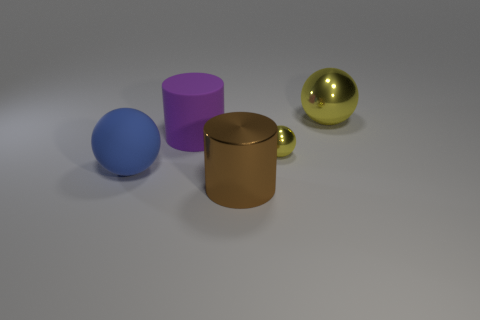Subtract all metal balls. How many balls are left? 1 Add 3 rubber cylinders. How many objects exist? 8 Subtract all blue balls. How many balls are left? 2 Subtract all cyan cylinders. How many blue spheres are left? 1 Subtract all big blue things. Subtract all small yellow matte things. How many objects are left? 4 Add 2 shiny balls. How many shiny balls are left? 4 Add 5 small yellow metallic spheres. How many small yellow metallic spheres exist? 6 Subtract 0 gray cubes. How many objects are left? 5 Subtract all balls. How many objects are left? 2 Subtract all gray spheres. Subtract all purple blocks. How many spheres are left? 3 